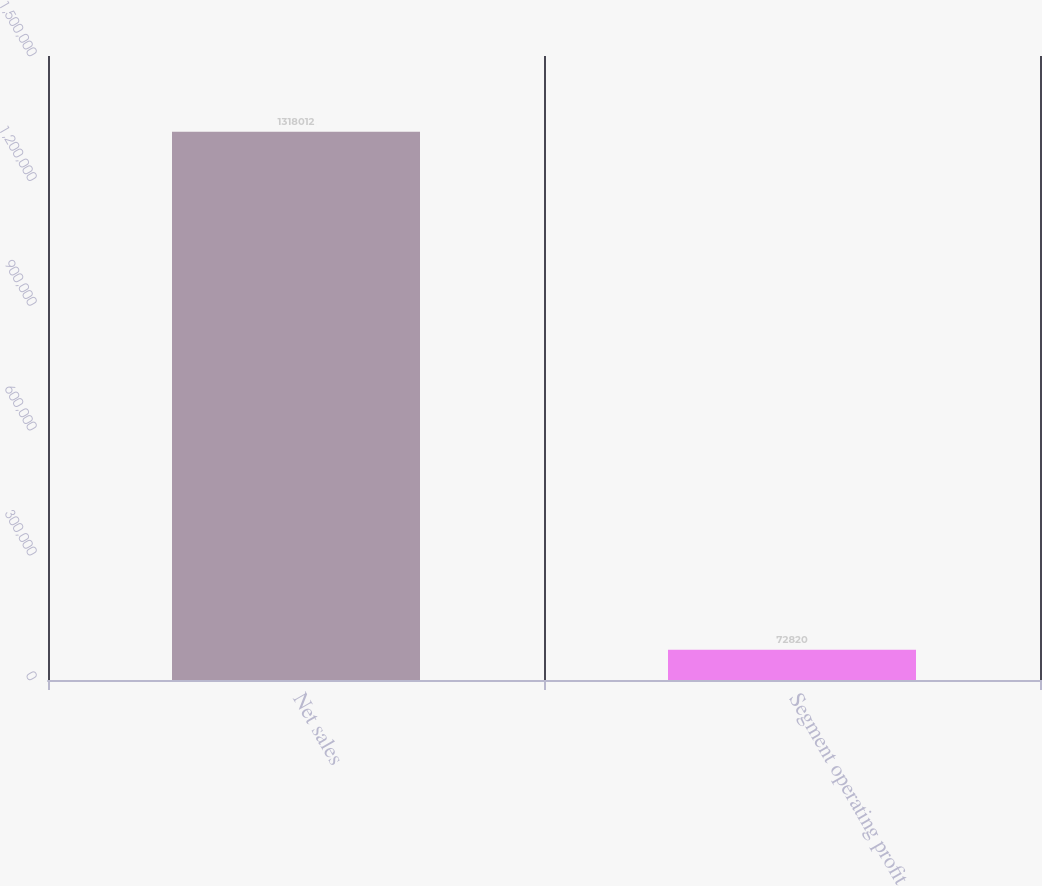Convert chart to OTSL. <chart><loc_0><loc_0><loc_500><loc_500><bar_chart><fcel>Net sales<fcel>Segment operating profit<nl><fcel>1.31801e+06<fcel>72820<nl></chart> 